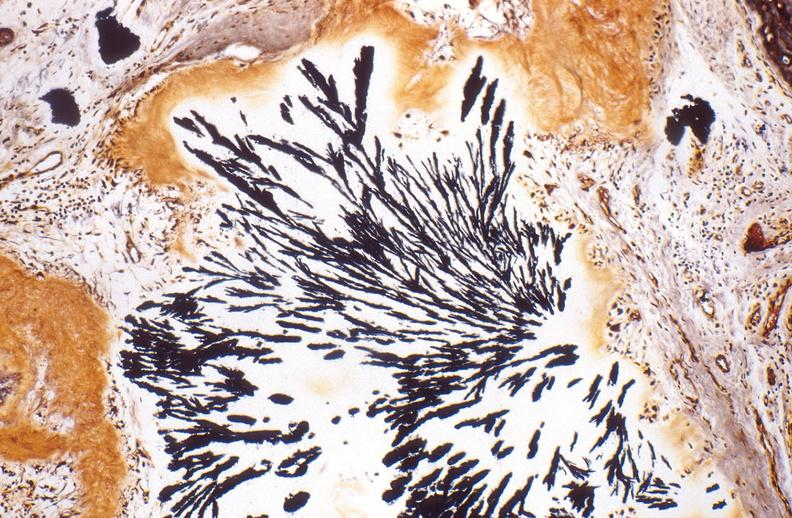what does this image show?
Answer the question using a single word or phrase. Gout 